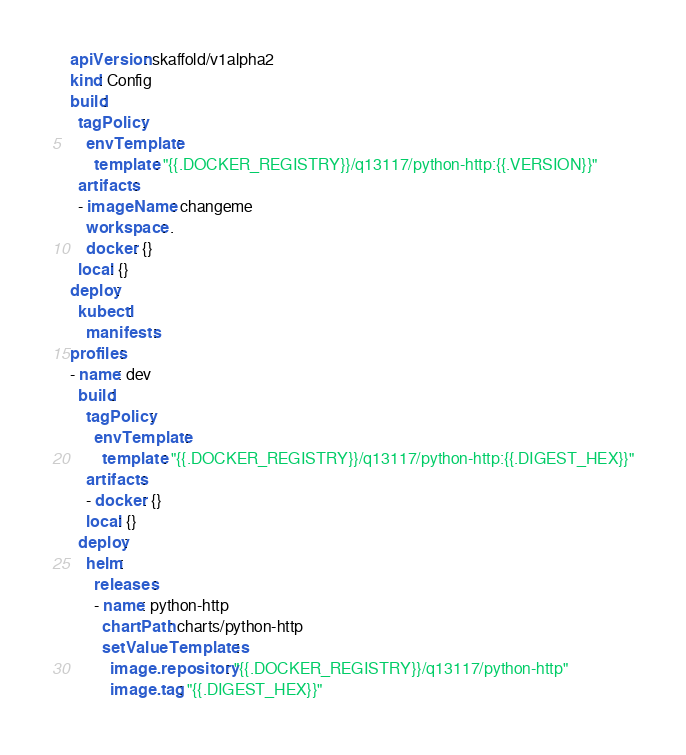Convert code to text. <code><loc_0><loc_0><loc_500><loc_500><_YAML_>apiVersion: skaffold/v1alpha2
kind: Config
build:
  tagPolicy:
    envTemplate:
      template: "{{.DOCKER_REGISTRY}}/q13117/python-http:{{.VERSION}}"
  artifacts:
  - imageName: changeme
    workspace: .
    docker: {}
  local: {}
deploy:
  kubectl:
    manifests:
profiles:
- name: dev
  build:
    tagPolicy:
      envTemplate:
        template: "{{.DOCKER_REGISTRY}}/q13117/python-http:{{.DIGEST_HEX}}"
    artifacts:
    - docker: {}
    local: {}
  deploy:
    helm:
      releases:
      - name: python-http
        chartPath: charts/python-http
        setValueTemplates:
          image.repository: "{{.DOCKER_REGISTRY}}/q13117/python-http"
          image.tag: "{{.DIGEST_HEX}}"
</code> 